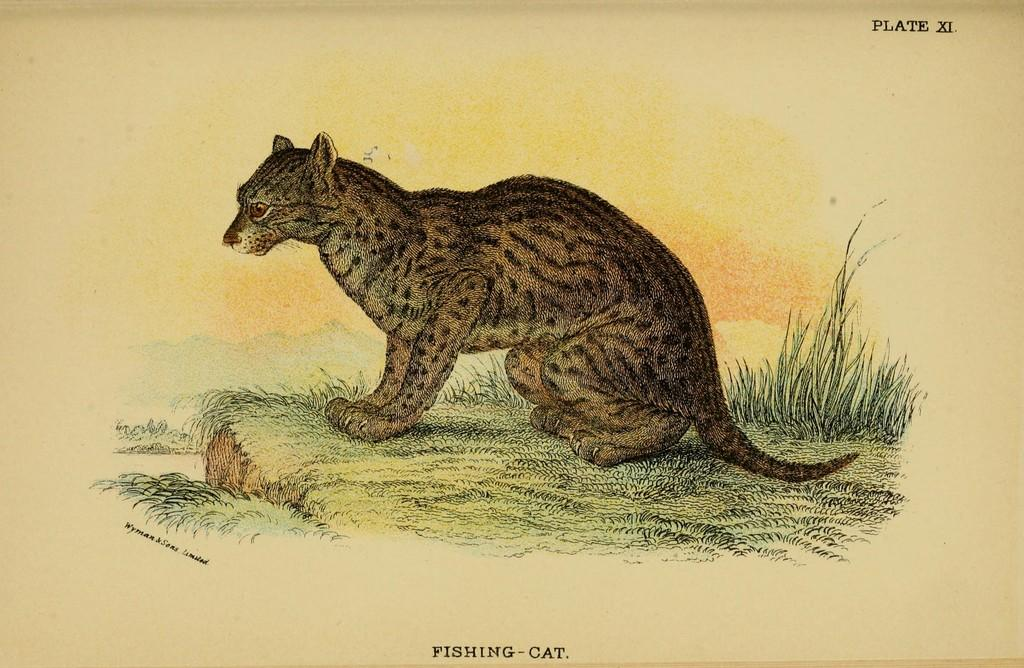What type of image is being described? The image is a poster. What animal is featured in the poster? There is a cat in the poster. What type of environment is depicted in the poster? There is grass in the poster. How much sugar is on the tray in the poster? There is no tray or sugar present in the poster; it features a cat in a grassy environment. 